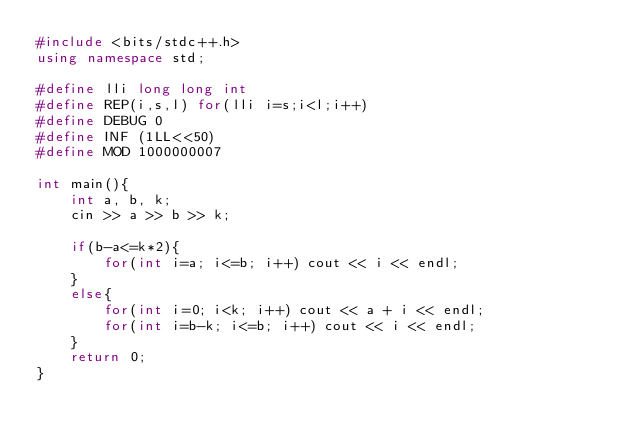<code> <loc_0><loc_0><loc_500><loc_500><_C++_>#include <bits/stdc++.h>
using namespace std;

#define lli long long int
#define REP(i,s,l) for(lli i=s;i<l;i++)
#define DEBUG 0
#define INF (1LL<<50)
#define MOD 1000000007

int main(){
    int a, b, k;
    cin >> a >> b >> k;

    if(b-a<=k*2){
        for(int i=a; i<=b; i++) cout << i << endl; 
    }
    else{
        for(int i=0; i<k; i++) cout << a + i << endl;
        for(int i=b-k; i<=b; i++) cout << i << endl;
    }
    return 0;
}</code> 